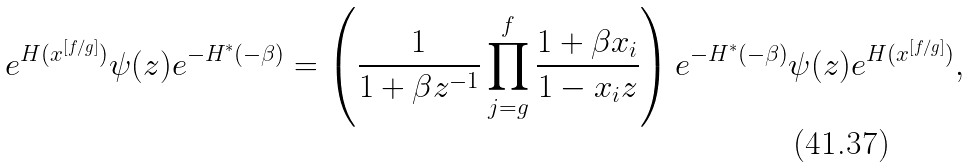<formula> <loc_0><loc_0><loc_500><loc_500>e ^ { H ( x ^ { [ f / g ] } ) } \psi ( z ) e ^ { - H ^ { \ast } ( - \beta ) } & = \left ( \frac { 1 } { 1 + \beta z ^ { - 1 } } \prod _ { j = g } ^ { f } \frac { 1 + \beta x _ { i } } { 1 - x _ { i } z } \right ) e ^ { - H ^ { \ast } ( - \beta ) } \psi ( z ) e ^ { H ( x ^ { [ f / g ] } ) } ,</formula> 